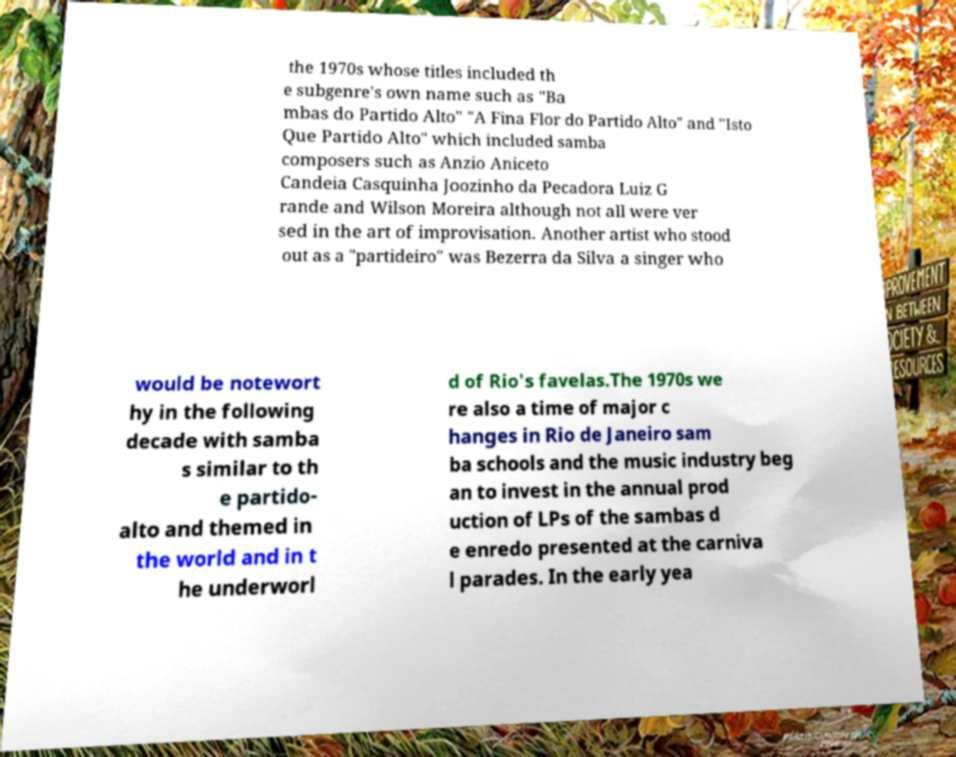For documentation purposes, I need the text within this image transcribed. Could you provide that? the 1970s whose titles included th e subgenre's own name such as "Ba mbas do Partido Alto" "A Fina Flor do Partido Alto" and "Isto Que Partido Alto" which included samba composers such as Anzio Aniceto Candeia Casquinha Joozinho da Pecadora Luiz G rande and Wilson Moreira although not all were ver sed in the art of improvisation. Another artist who stood out as a "partideiro" was Bezerra da Silva a singer who would be notewort hy in the following decade with samba s similar to th e partido- alto and themed in the world and in t he underworl d of Rio's favelas.The 1970s we re also a time of major c hanges in Rio de Janeiro sam ba schools and the music industry beg an to invest in the annual prod uction of LPs of the sambas d e enredo presented at the carniva l parades. In the early yea 